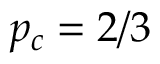<formula> <loc_0><loc_0><loc_500><loc_500>p _ { c } = 2 / 3</formula> 